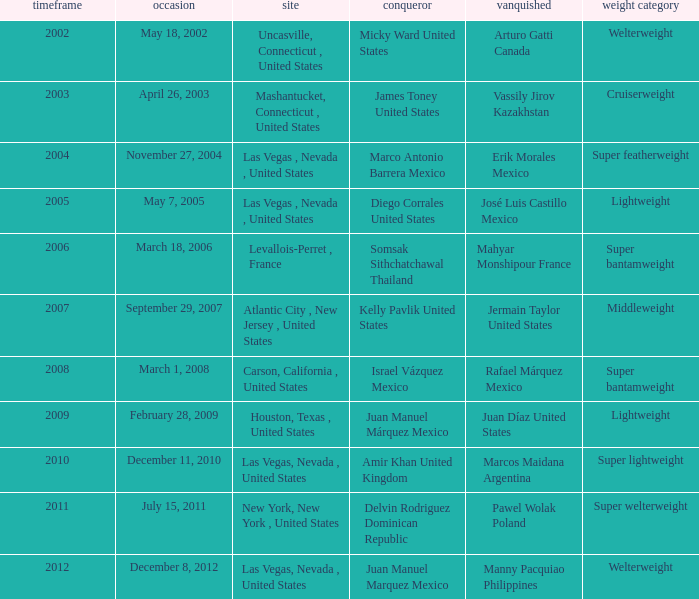How many years were lightweight class on february 28, 2009? 1.0. 